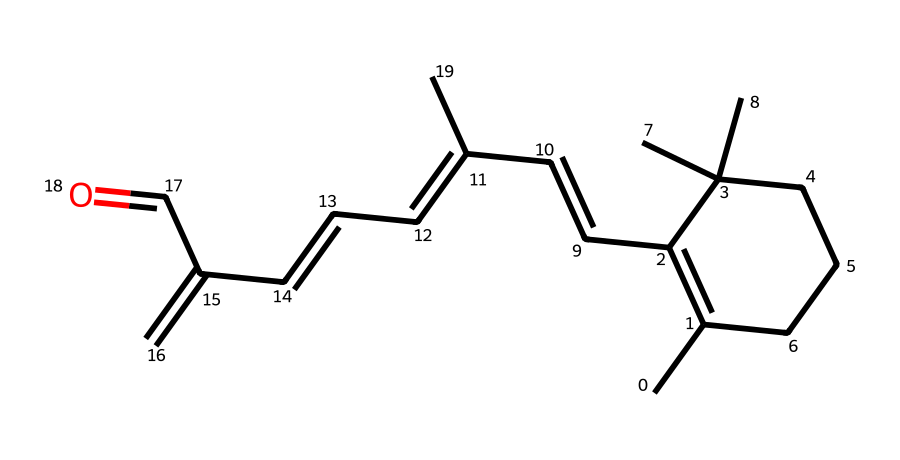What is the common name for this chemical? The chemical structure corresponds to retinol, a well-known compound utilized in anti-aging and skin-care products. The presence of the specific functional groups and general structure indicates its identity.
Answer: retinol How many double bonds are present in the structure? By examining the SMILES representation, we can identify double bonds specified by "=". Counting these within the structure reveals that there are three double bonds in total.
Answer: 3 What type of functional group is present in this molecule? The molecule contains an aliphatic aldehyde functional group, indicated by the presence of a carbon atom connected to a carbonyl group (C=O) and a hydrogen atom. This can be deduced from the terminal structure visible in the SMILES notation.
Answer: aldehyde What is the molecular formula for retinol? By interpreting the counts of carbon (C), hydrogen (H), and oxygen (O) from the chemical structure based on the SMILES representation, we can derive the full molecular formula. For retinol, the count totals to C20H30O.
Answer: C20H30O Does the presence of rings indicate aromatic properties? The chemical structure includes a cyclohexene ring, which has double bonds and contributes to unsaturation. However, the molecule overall does not exhibit the characteristics of aromatic compounds, as it lacks a full conjugated system of p-orbitals needed for aromaticity. Thus, while there are cyclic structures, they do not denote aromatic properties in this case.
Answer: No 